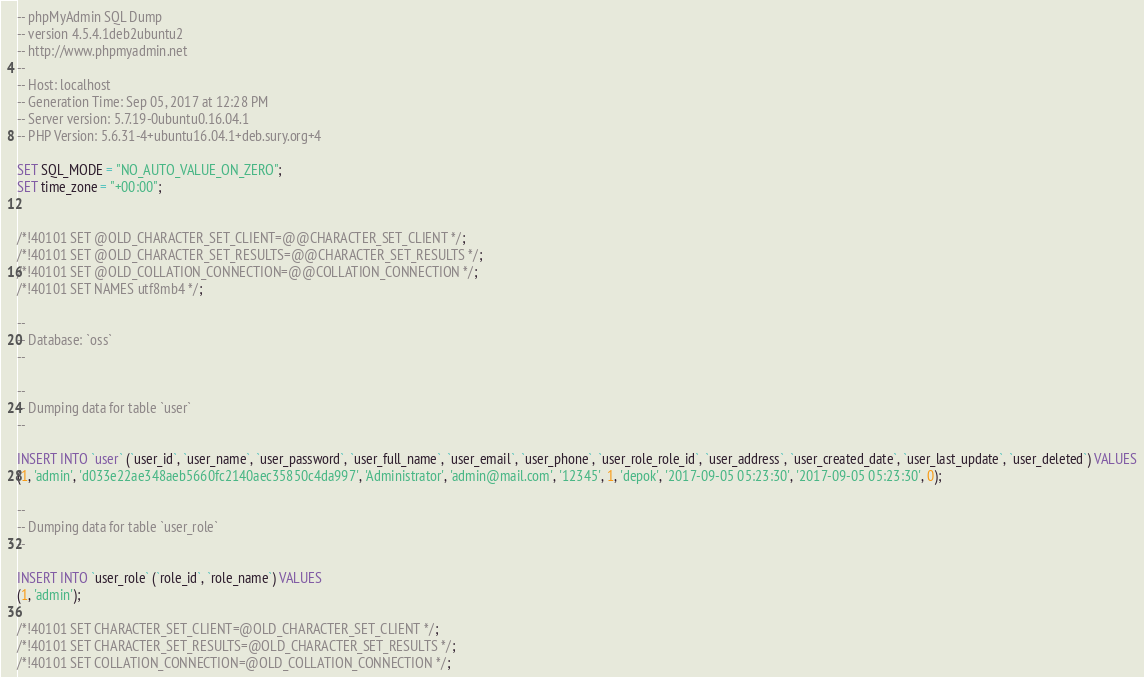Convert code to text. <code><loc_0><loc_0><loc_500><loc_500><_SQL_>-- phpMyAdmin SQL Dump
-- version 4.5.4.1deb2ubuntu2
-- http://www.phpmyadmin.net
--
-- Host: localhost
-- Generation Time: Sep 05, 2017 at 12:28 PM
-- Server version: 5.7.19-0ubuntu0.16.04.1
-- PHP Version: 5.6.31-4+ubuntu16.04.1+deb.sury.org+4

SET SQL_MODE = "NO_AUTO_VALUE_ON_ZERO";
SET time_zone = "+00:00";


/*!40101 SET @OLD_CHARACTER_SET_CLIENT=@@CHARACTER_SET_CLIENT */;
/*!40101 SET @OLD_CHARACTER_SET_RESULTS=@@CHARACTER_SET_RESULTS */;
/*!40101 SET @OLD_COLLATION_CONNECTION=@@COLLATION_CONNECTION */;
/*!40101 SET NAMES utf8mb4 */;

--
-- Database: `oss`
--

--
-- Dumping data for table `user`
--

INSERT INTO `user` (`user_id`, `user_name`, `user_password`, `user_full_name`, `user_email`, `user_phone`, `user_role_role_id`, `user_address`, `user_created_date`, `user_last_update`, `user_deleted`) VALUES
(1, 'admin', 'd033e22ae348aeb5660fc2140aec35850c4da997', 'Administrator', 'admin@mail.com', '12345', 1, 'depok', '2017-09-05 05:23:30', '2017-09-05 05:23:30', 0);

--
-- Dumping data for table `user_role`
--

INSERT INTO `user_role` (`role_id`, `role_name`) VALUES
(1, 'admin');

/*!40101 SET CHARACTER_SET_CLIENT=@OLD_CHARACTER_SET_CLIENT */;
/*!40101 SET CHARACTER_SET_RESULTS=@OLD_CHARACTER_SET_RESULTS */;
/*!40101 SET COLLATION_CONNECTION=@OLD_COLLATION_CONNECTION */;
</code> 